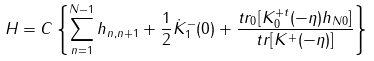<formula> <loc_0><loc_0><loc_500><loc_500>H = C \left \{ \sum _ { n = 1 } ^ { N - 1 } h _ { n , n + 1 } + \frac { 1 } { 2 } \dot { K } _ { 1 } ^ { - } ( 0 ) + \frac { t r _ { 0 } [ K _ { 0 } ^ { + t } ( - \eta ) h _ { N 0 } ] } { t r [ K ^ { + } ( - \eta ) ] } \right \}</formula> 